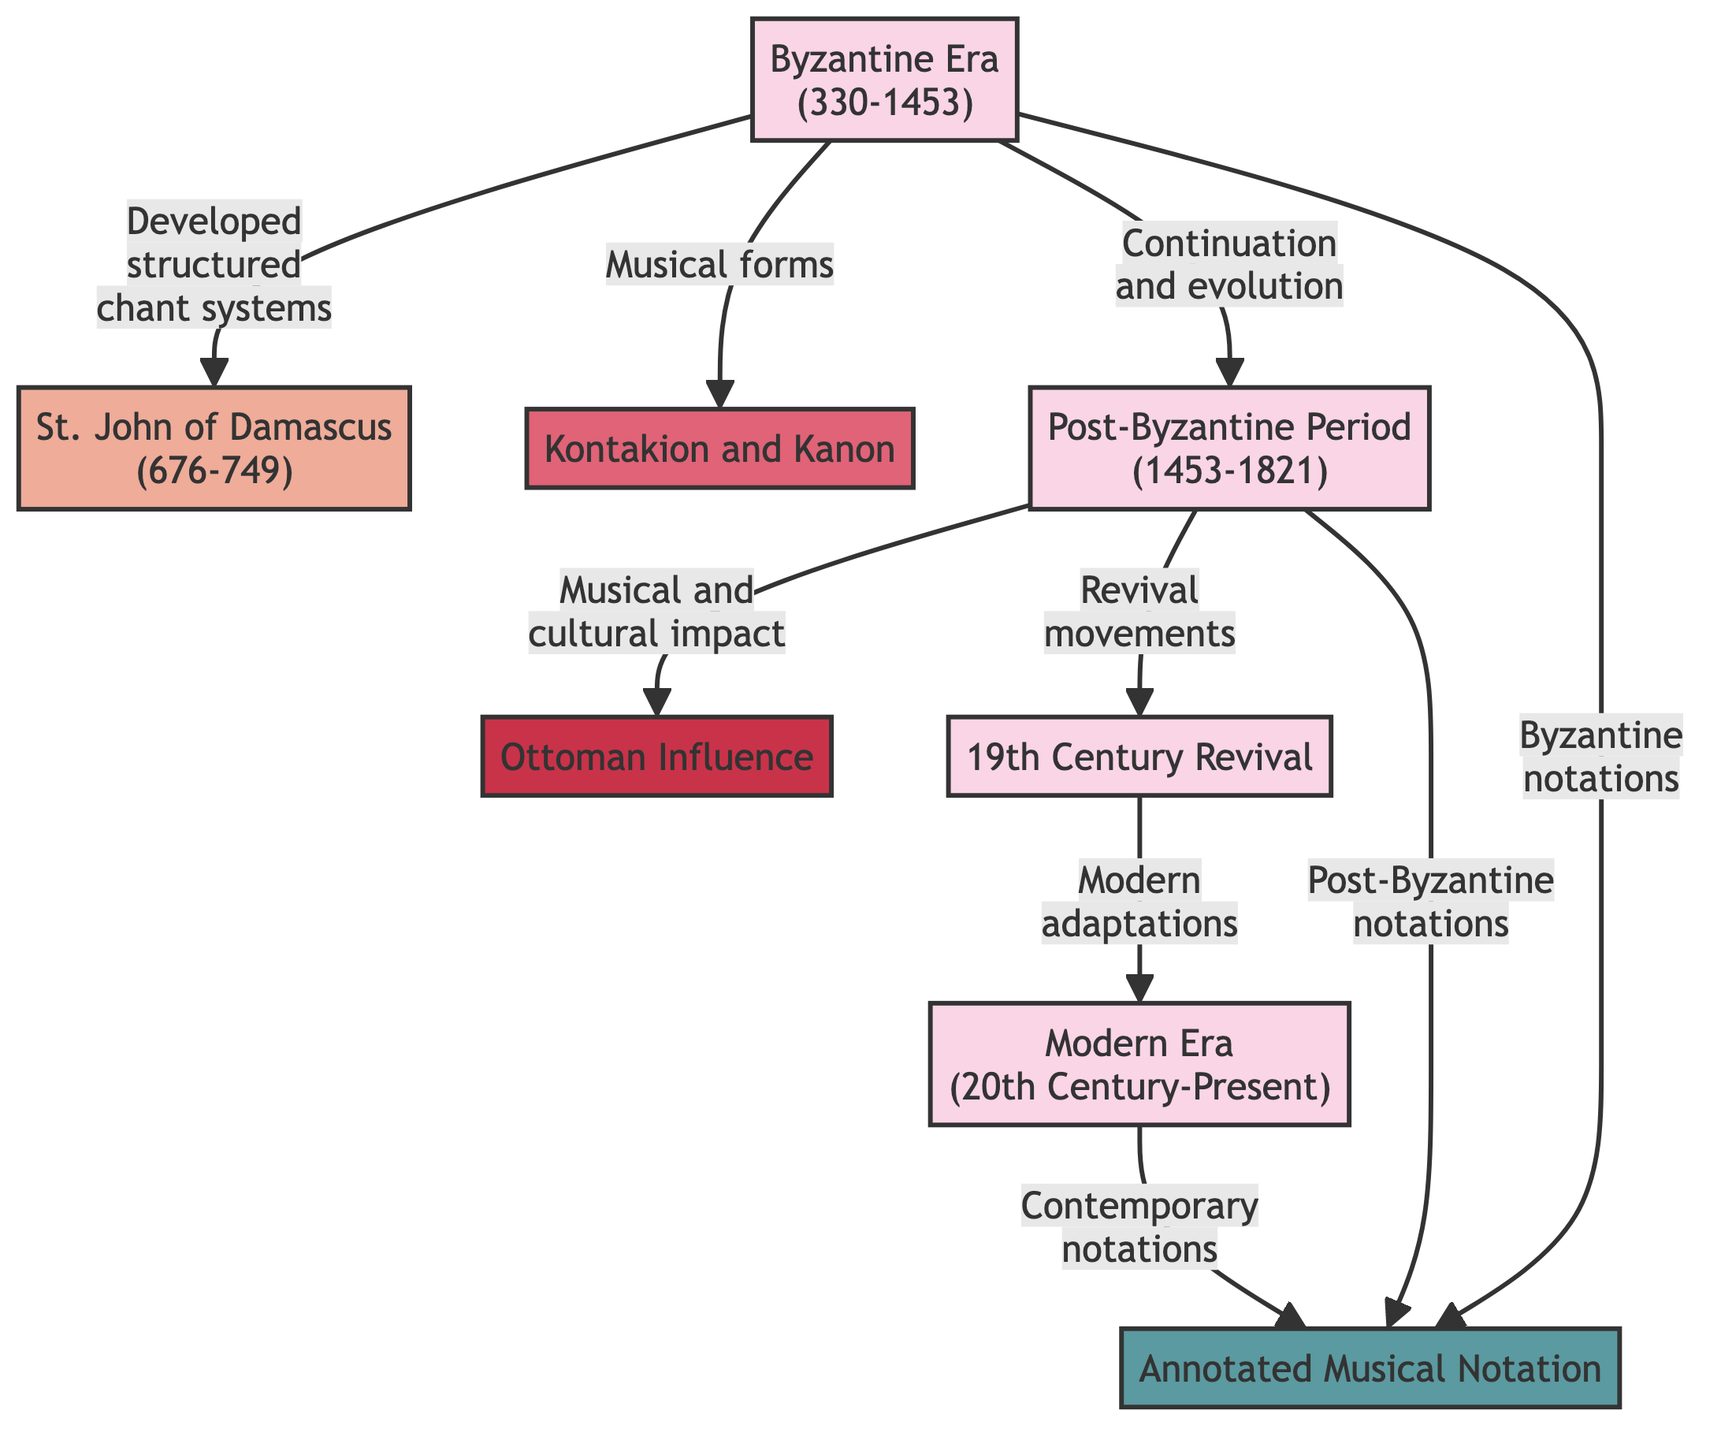What is the first period in the timeline? The timeline starts with the "Byzantine Era (330-1453)" as the first period indicated in the diagram. This can be confirmed by identifying the first node presented at the top of the flowchart.
Answer: Byzantine Era (330-1453) Which key figure is associated with the Byzantine Era? The diagram identifies "St. John of Damascus (676-749)" as a key figure associated with the Byzantine Era through a direct link from the Byzantine Era node. This is derived from the connection shown beneath the Byzantine Era.
Answer: St. John of Damascus (676-749) What are the two musical forms indicated in the Byzantine Era? The musical forms listed under the Byzantine Era are "Kontakion and Kanon." This can be confirmed by looking at the linked node directly related to the Byzantine Era node that indicates these forms.
Answer: Kontakion and Kanon What influence is described during the Post-Byzantine Period? The influence described during the Post-Byzantine Period is "Ottoman Influence." This information can be gathered from the direct link between the post-Byzantine node and the Ottoman influence node in the diagram.
Answer: Ottoman Influence How many forms of notation are mentioned in the diagram? The diagram indicates three forms of notation: "Byzantine notations," "Post-Byzantine notations," and "Contemporary notations." By counting each linked notation that emerges from the Byzantine era, post-Byzantine, and modern era nodes, we determine the total.
Answer: Three What type of influence is connected to the 19th Century Revival? The connection from the 19th Century Revival node shows "Modern adaptations." This relationship can be traced by following the link from the 19th Century Revival leading directly to the modern era node reflecting adaptations.
Answer: Modern adaptations Which era does the annotated musical notation first get introduced? The annotated musical notation is first introduced in the "Byzantine Era" as indicated by the direct link connecting it from the Byzantine Era node. This is evident as the initial association made with the notation in the diagram.
Answer: Byzantine Era Which period follows the Post-Byzantine Period in the timeline? The period that directly follows the Post-Byzantine Period in the timeline is the "19th Century Revival." This is established by exploring the flow from the Post-Byzantine node to its successor in the diagram.
Answer: 19th Century Revival What relationship does the modern era have with the annotated notation? The modern era's relationship with annotated notation is "Contemporary notations." This relationship is shown by a direct link that connects the modern era node to the annotated notation node in the visual representation.
Answer: Contemporary notations 